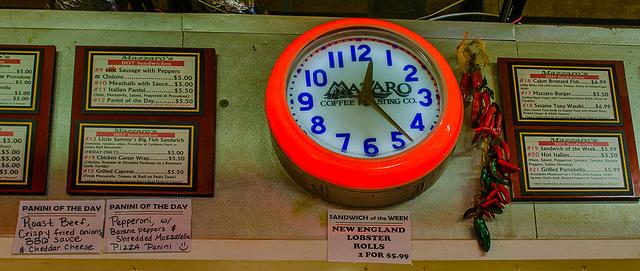What color is around the clock?
Concise answer only. Red. What information is on the signs?
Short answer required. Menu. What is the clock for?
Write a very short answer. Telling time. What time is shown on the clock?
Answer briefly. 12:24. What does the neon sign say?
Keep it brief. Mazzaro. How do most people feel when they see this?
Keep it brief. Hungry. 